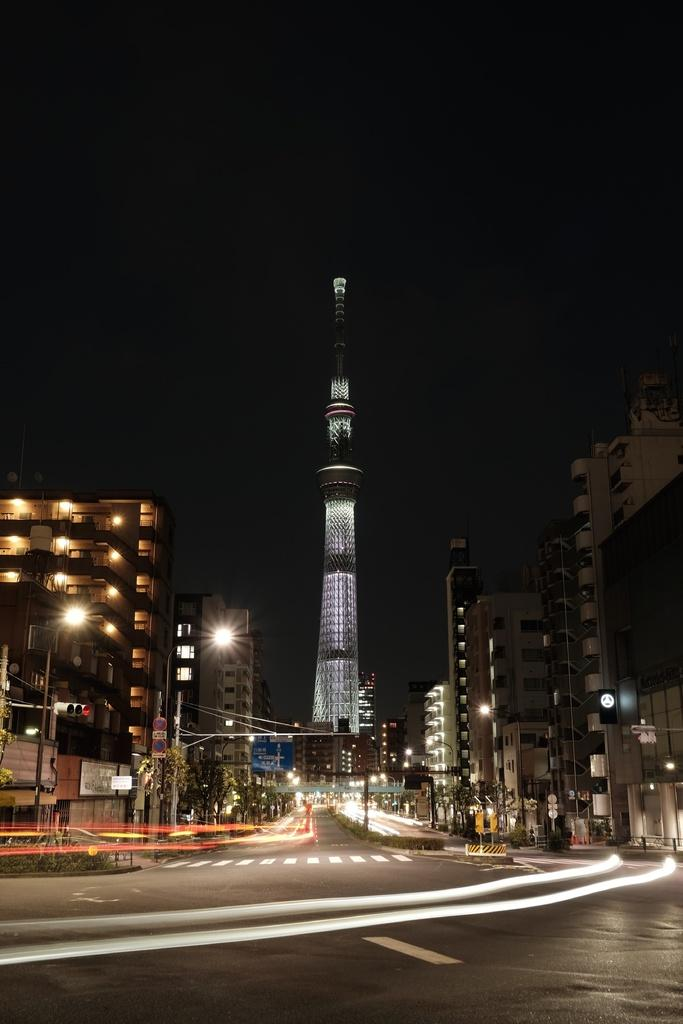What type of structures can be seen in the image? There are buildings in the image. What else is present in the image besides buildings? There are poles, lights, and trees in the image. How would you describe the lighting in the image? The lights in the image provide illumination. What can be observed about the background of the image? The background of the image is dark. How many visitors are present in the market in the image? There is no market or visitors present in the image. What direction is the way leading to in the image? There is no way or directional path visible in the image. 